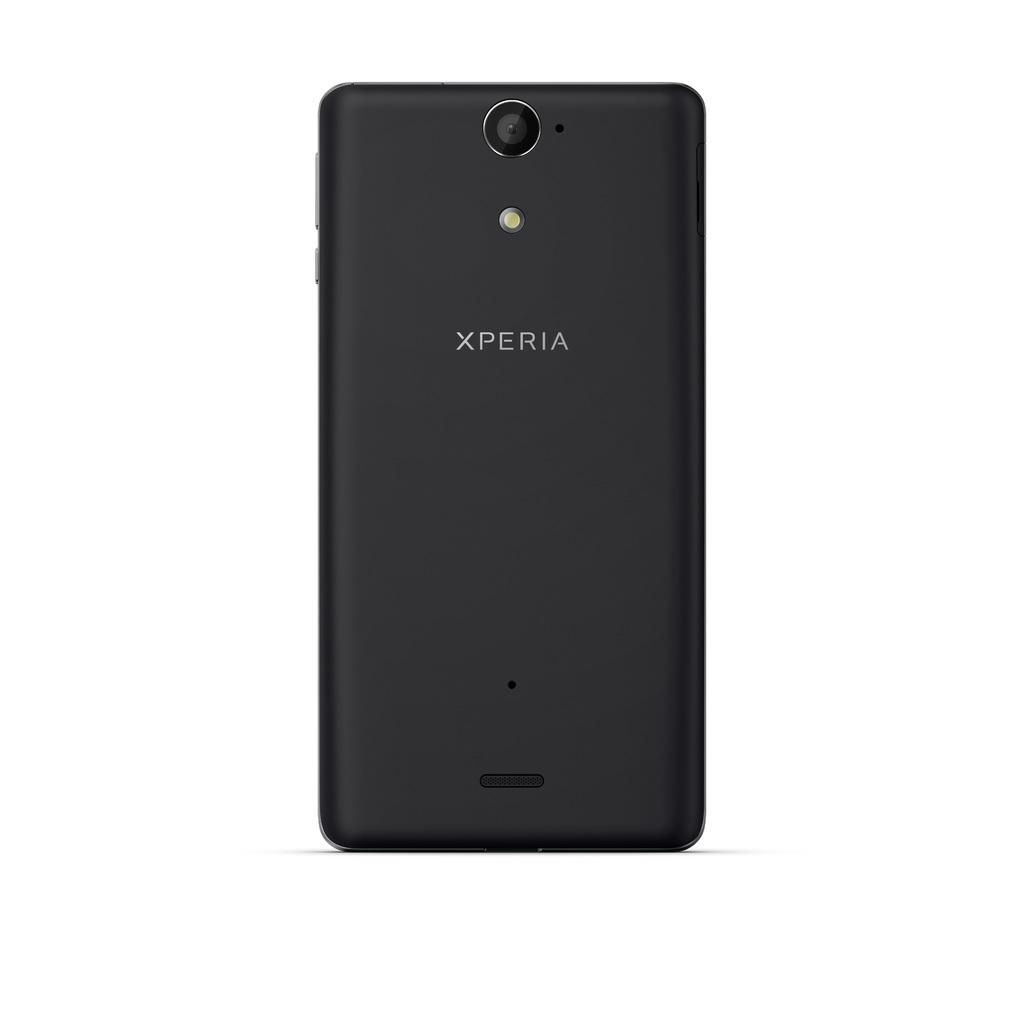What make is this phone?
Keep it short and to the point. Xperia. 